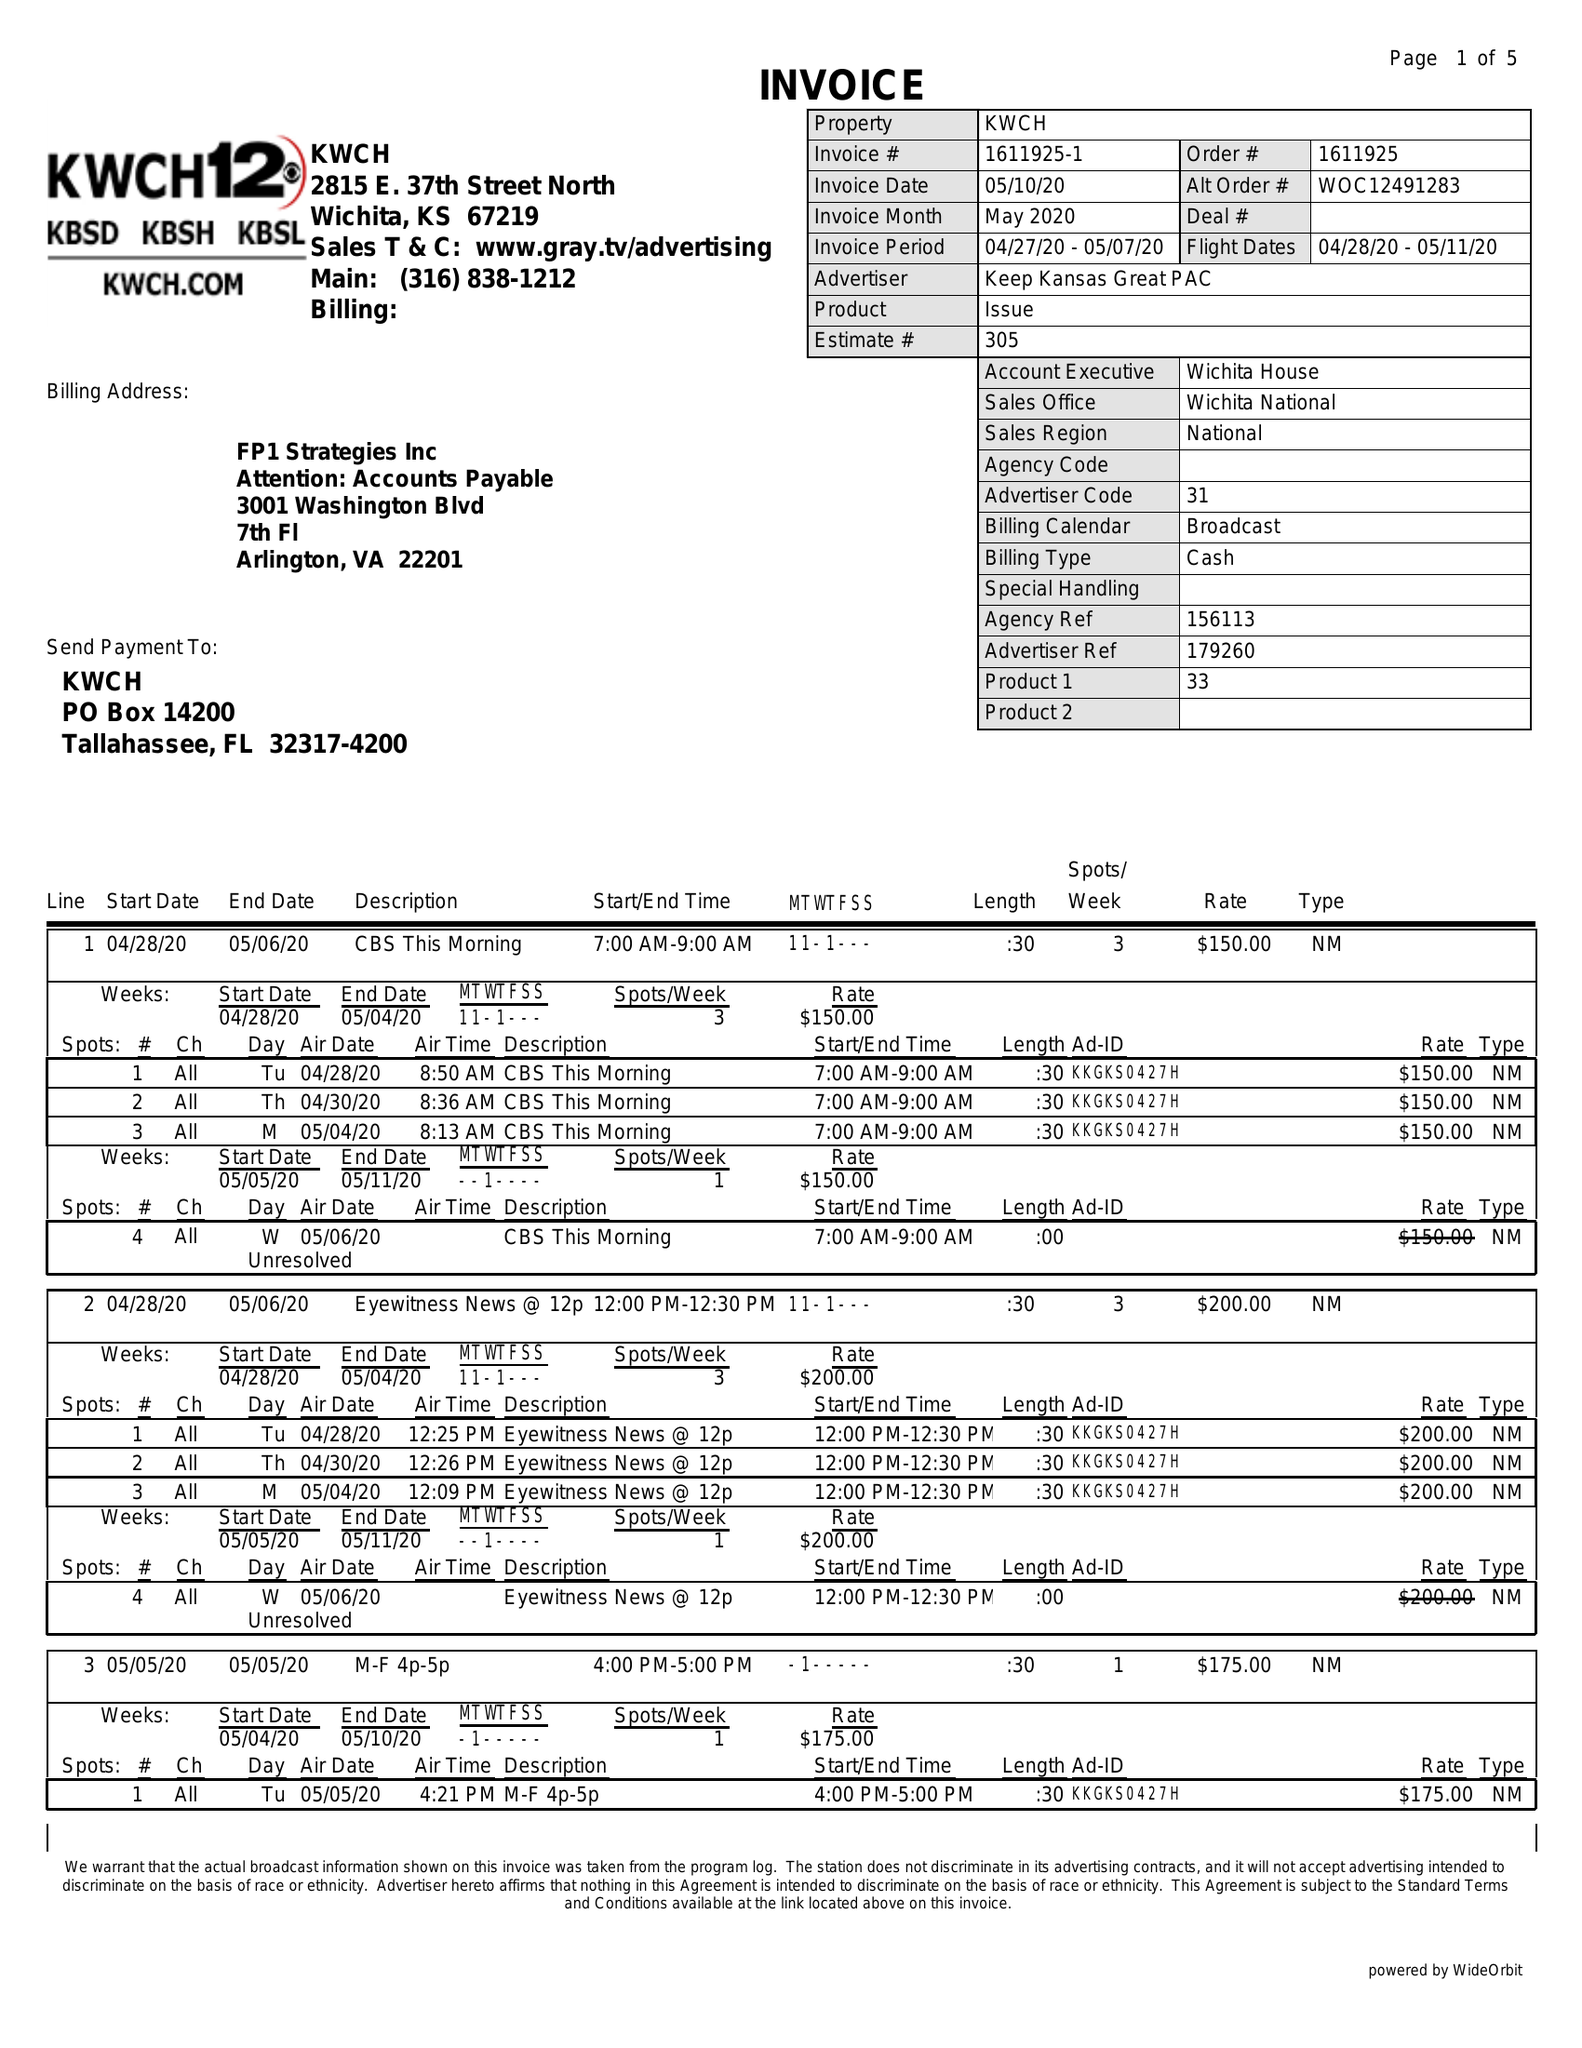What is the value for the flight_from?
Answer the question using a single word or phrase. 04/28/20 